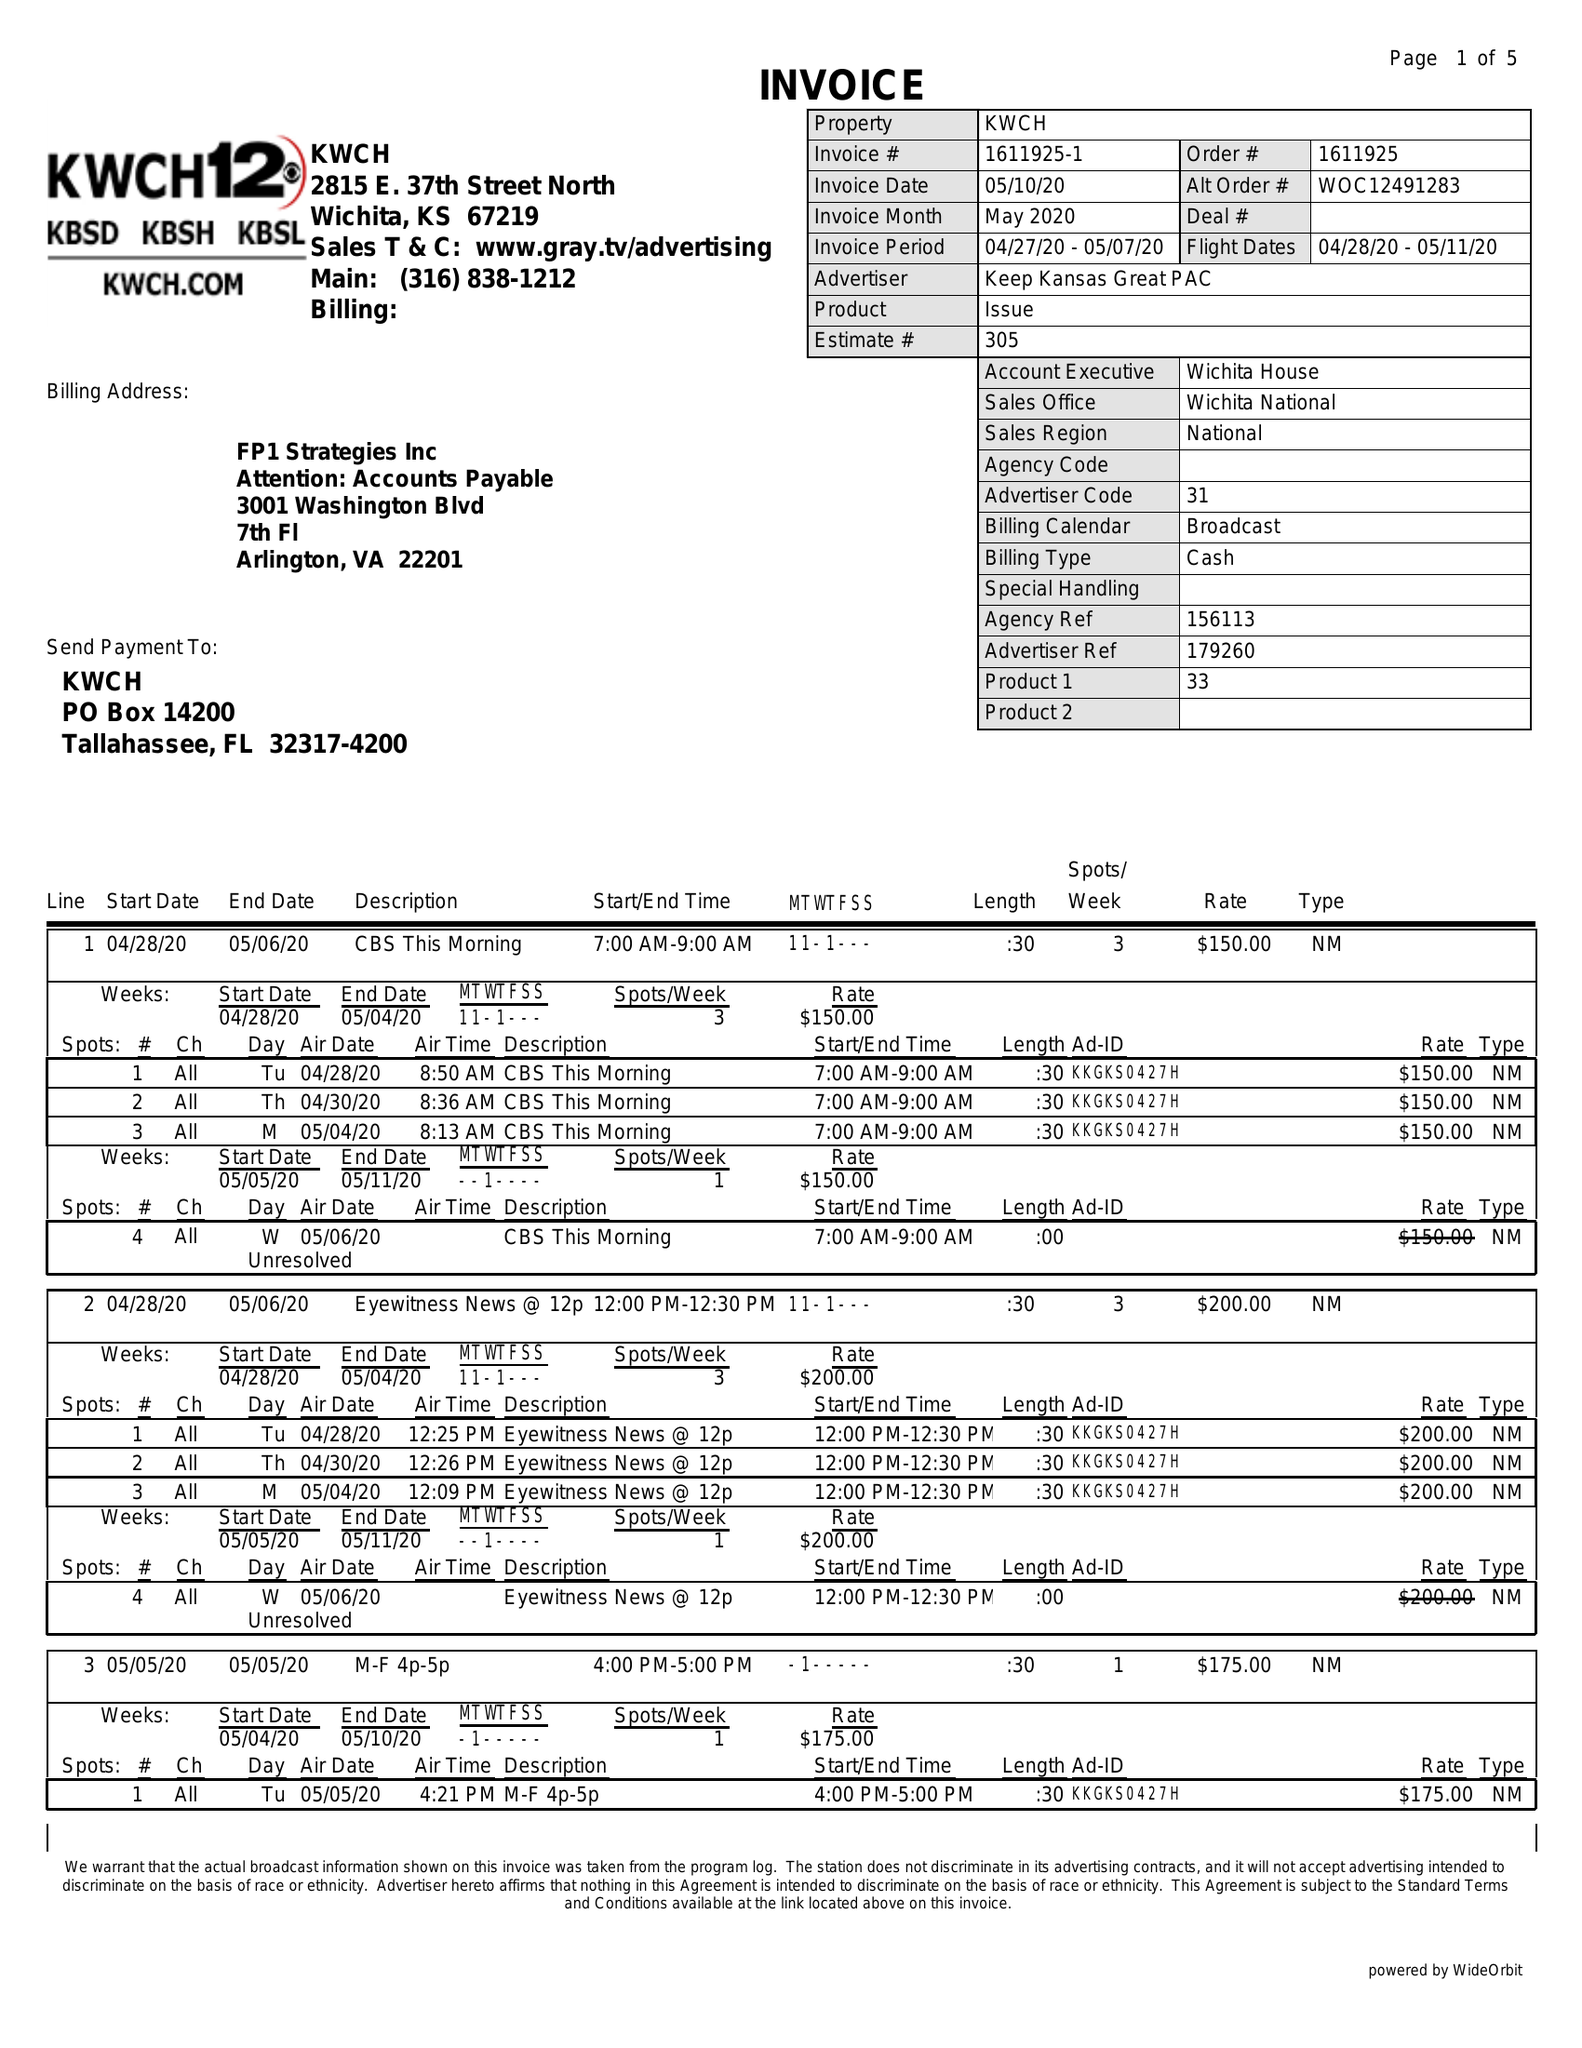What is the value for the flight_from?
Answer the question using a single word or phrase. 04/28/20 